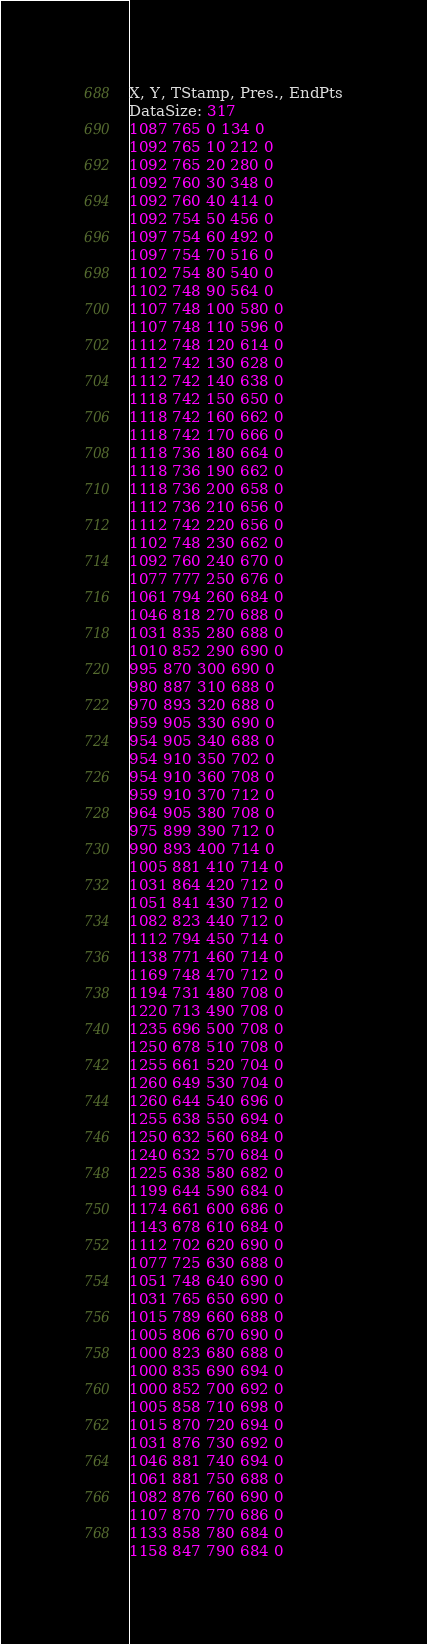<code> <loc_0><loc_0><loc_500><loc_500><_SML_>X, Y, TStamp, Pres., EndPts
DataSize: 317
1087 765 0 134 0
1092 765 10 212 0
1092 765 20 280 0
1092 760 30 348 0
1092 760 40 414 0
1092 754 50 456 0
1097 754 60 492 0
1097 754 70 516 0
1102 754 80 540 0
1102 748 90 564 0
1107 748 100 580 0
1107 748 110 596 0
1112 748 120 614 0
1112 742 130 628 0
1112 742 140 638 0
1118 742 150 650 0
1118 742 160 662 0
1118 742 170 666 0
1118 736 180 664 0
1118 736 190 662 0
1118 736 200 658 0
1112 736 210 656 0
1112 742 220 656 0
1102 748 230 662 0
1092 760 240 670 0
1077 777 250 676 0
1061 794 260 684 0
1046 818 270 688 0
1031 835 280 688 0
1010 852 290 690 0
995 870 300 690 0
980 887 310 688 0
970 893 320 688 0
959 905 330 690 0
954 905 340 688 0
954 910 350 702 0
954 910 360 708 0
959 910 370 712 0
964 905 380 708 0
975 899 390 712 0
990 893 400 714 0
1005 881 410 714 0
1031 864 420 712 0
1051 841 430 712 0
1082 823 440 712 0
1112 794 450 714 0
1138 771 460 714 0
1169 748 470 712 0
1194 731 480 708 0
1220 713 490 708 0
1235 696 500 708 0
1250 678 510 708 0
1255 661 520 704 0
1260 649 530 704 0
1260 644 540 696 0
1255 638 550 694 0
1250 632 560 684 0
1240 632 570 684 0
1225 638 580 682 0
1199 644 590 684 0
1174 661 600 686 0
1143 678 610 684 0
1112 702 620 690 0
1077 725 630 688 0
1051 748 640 690 0
1031 765 650 690 0
1015 789 660 688 0
1005 806 670 690 0
1000 823 680 688 0
1000 835 690 694 0
1000 852 700 692 0
1005 858 710 698 0
1015 870 720 694 0
1031 876 730 692 0
1046 881 740 694 0
1061 881 750 688 0
1082 876 760 690 0
1107 870 770 686 0
1133 858 780 684 0
1158 847 790 684 0</code> 